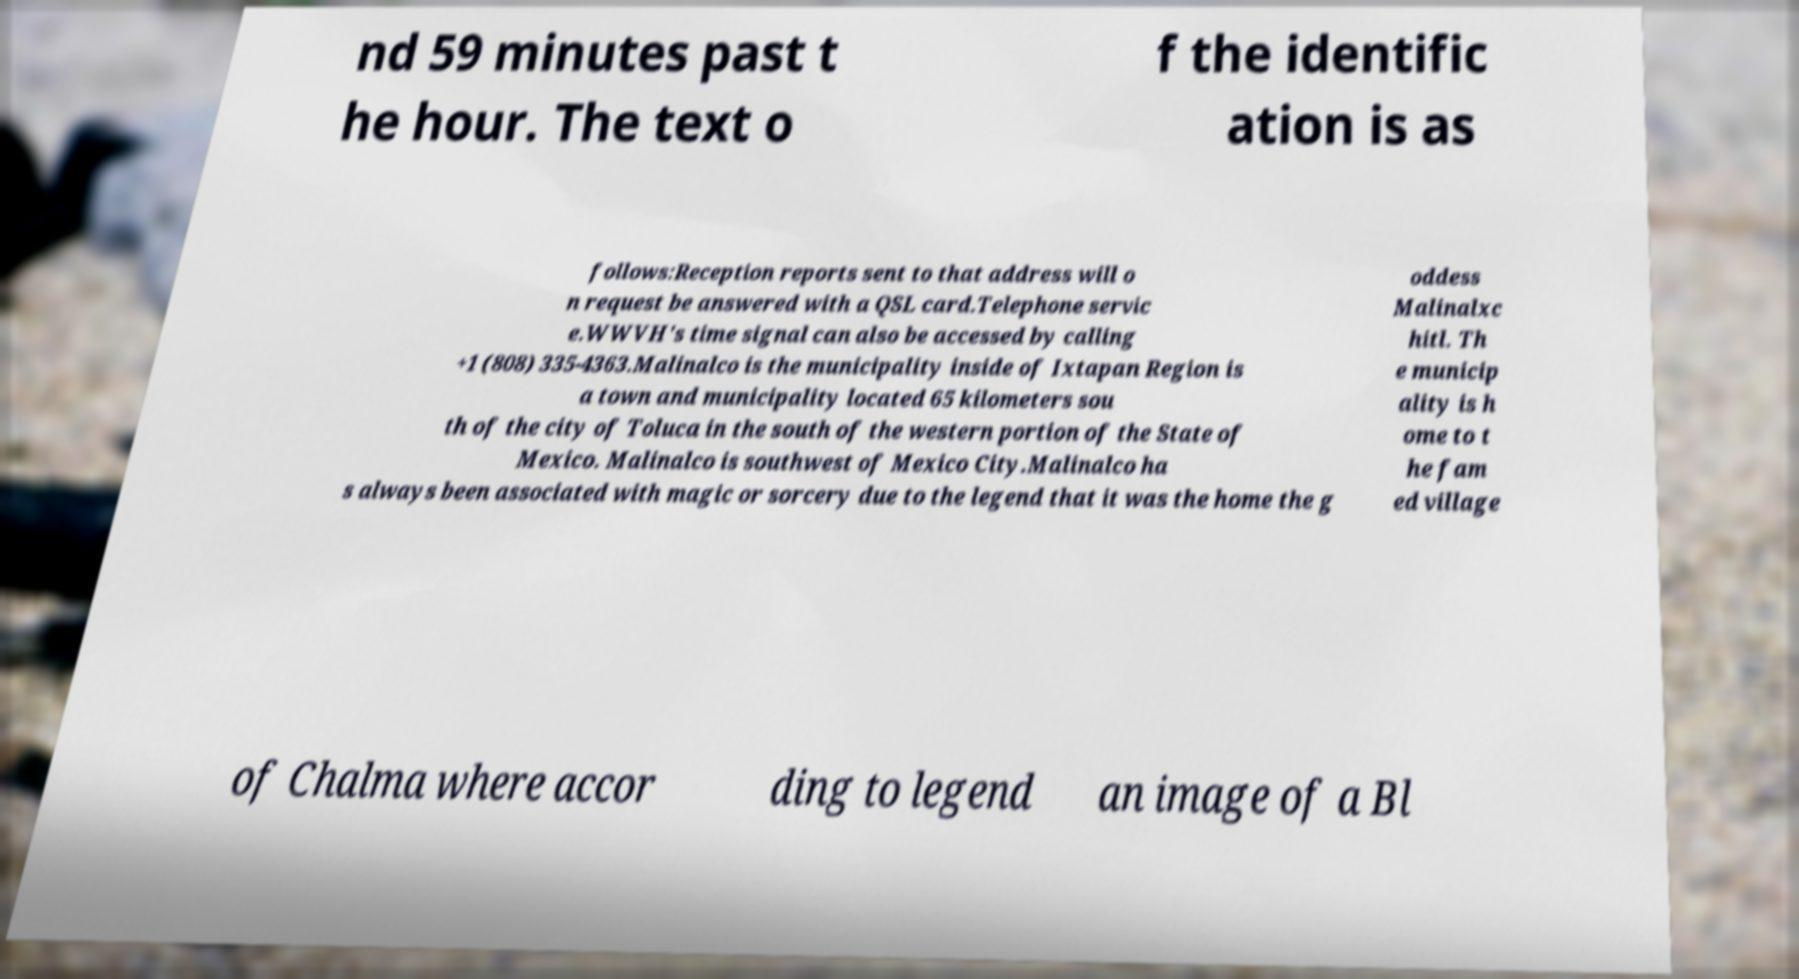There's text embedded in this image that I need extracted. Can you transcribe it verbatim? nd 59 minutes past t he hour. The text o f the identific ation is as follows:Reception reports sent to that address will o n request be answered with a QSL card.Telephone servic e.WWVH's time signal can also be accessed by calling +1 (808) 335-4363.Malinalco is the municipality inside of Ixtapan Region is a town and municipality located 65 kilometers sou th of the city of Toluca in the south of the western portion of the State of Mexico. Malinalco is southwest of Mexico City.Malinalco ha s always been associated with magic or sorcery due to the legend that it was the home the g oddess Malinalxc hitl. Th e municip ality is h ome to t he fam ed village of Chalma where accor ding to legend an image of a Bl 